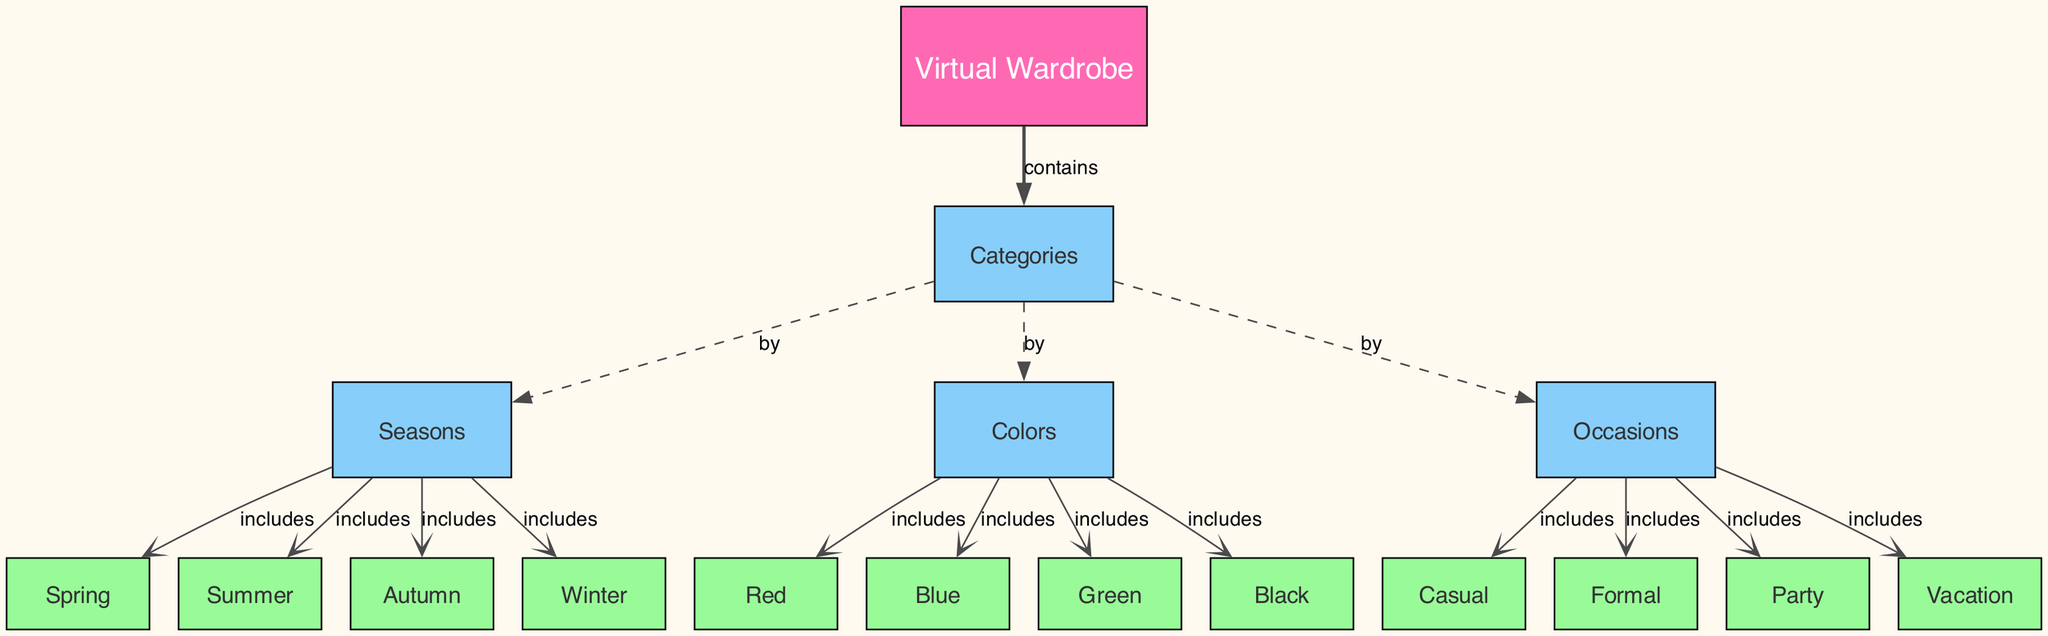What is the root node of the diagram? The root node is identified as the starting point of the diagram structure, which is "Virtual Wardrobe." It is the first node listed and acts as a parent to all others.
Answer: Virtual Wardrobe How many seasons are listed in the wardrobe organization? The diagram displays four distinct seasons, which are directly shown as leaf nodes under the sub-node "Seasons": Spring, Summer, Autumn, and Winter. Counting these gives a total of four.
Answer: 4 Which categories can users organize their wardrobe by? The categories through which users can organize their wardrobe, represented by sub-nodes under the "Categories" node, include "Seasons," "Colors," and "Occasions." These are the primary ways to classify their wardrobe items.
Answer: Seasons, Colors, Occasions How many color options are available in the virtual wardrobe? The diagram includes four color options: Red, Blue, Green, and Black, each of which is a leaf node under the "Colors" sub-node. Therefore, a total of four color options are available.
Answer: 4 What occasion in the diagram is listed first under the "Occasions" sub-node? The diagram sequentially lists occasions under the "Occasions" sub-node, with "Casual" appearing first as the first leaf node in that category.
Answer: Casual Which season does the diagram link to the most occasions? To find out, we observe that occasions are indirectly associated with seasons since there's no direct link of seasons to occasions; however, all seasons can include any occasion, thus suggesting that visually, all seasons share equal occasion potential. However, for this context, we could say “All seasons” as they contain the same nodes.
Answer: All seasons How many edges are associated with the “Categories” node? The "Categories" node connects to three sub-nodes: "Seasons," "Colors," and "Occasions." Each connection is represented by an edge in the diagram. Thus, there are a total of three edges.
Answer: 3 What relationship connects "Categories" to "Seasons"? The relationship depicted between "Categories" and "Seasons" in the diagram is labeled as "by," represented with a dashed line connecting the two. This signifies that the category of wardrobe items can be organized by season.
Answer: by What color is assigned to leaf nodes in the diagram? In the diagram, leaf nodes, which represent specific items like individual seasons or color options, are colored with a specific shade designated in the colors section of the code - "#98FB98." This distinguishes them from sub-nodes and the root node, which have different colors.
Answer: #98FB98 